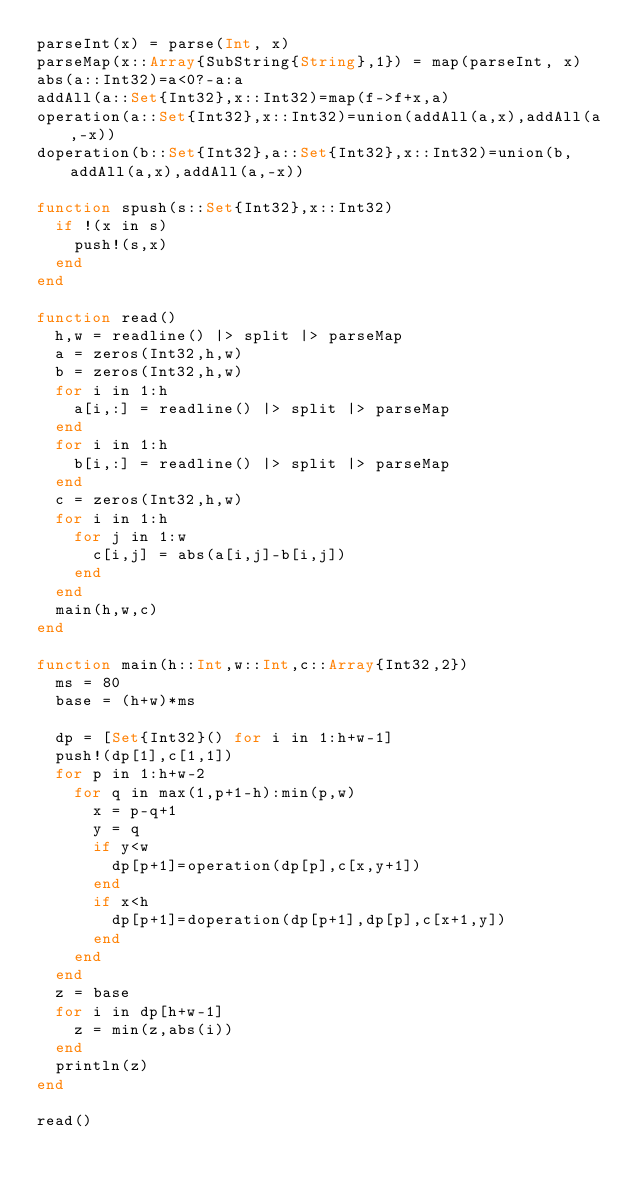<code> <loc_0><loc_0><loc_500><loc_500><_Julia_>parseInt(x) = parse(Int, x)
parseMap(x::Array{SubString{String},1}) = map(parseInt, x)
abs(a::Int32)=a<0?-a:a
addAll(a::Set{Int32},x::Int32)=map(f->f+x,a)
operation(a::Set{Int32},x::Int32)=union(addAll(a,x),addAll(a,-x))
doperation(b::Set{Int32},a::Set{Int32},x::Int32)=union(b,addAll(a,x),addAll(a,-x))

function spush(s::Set{Int32},x::Int32)
	if !(x in s)
		push!(s,x)
	end
end

function read()
	h,w = readline() |> split |> parseMap
	a = zeros(Int32,h,w)
	b = zeros(Int32,h,w)
	for i in 1:h
		a[i,:] = readline() |> split |> parseMap
	end
	for i in 1:h
		b[i,:] = readline() |> split |> parseMap
	end
	c = zeros(Int32,h,w)
	for i in 1:h
		for j in 1:w
			c[i,j] = abs(a[i,j]-b[i,j])
		end
	end
	main(h,w,c)
end

function main(h::Int,w::Int,c::Array{Int32,2})
	ms = 80
	base = (h+w)*ms
	
	dp = [Set{Int32}() for i in 1:h+w-1]
	push!(dp[1],c[1,1])
	for p in 1:h+w-2
		for q in max(1,p+1-h):min(p,w)
			x = p-q+1
			y = q
			if y<w
				dp[p+1]=operation(dp[p],c[x,y+1])
			end
			if x<h
				dp[p+1]=doperation(dp[p+1],dp[p],c[x+1,y])
			end
		end
	end
	z = base
	for i in dp[h+w-1]
		z = min(z,abs(i))
	end
	println(z)
end

read()

</code> 